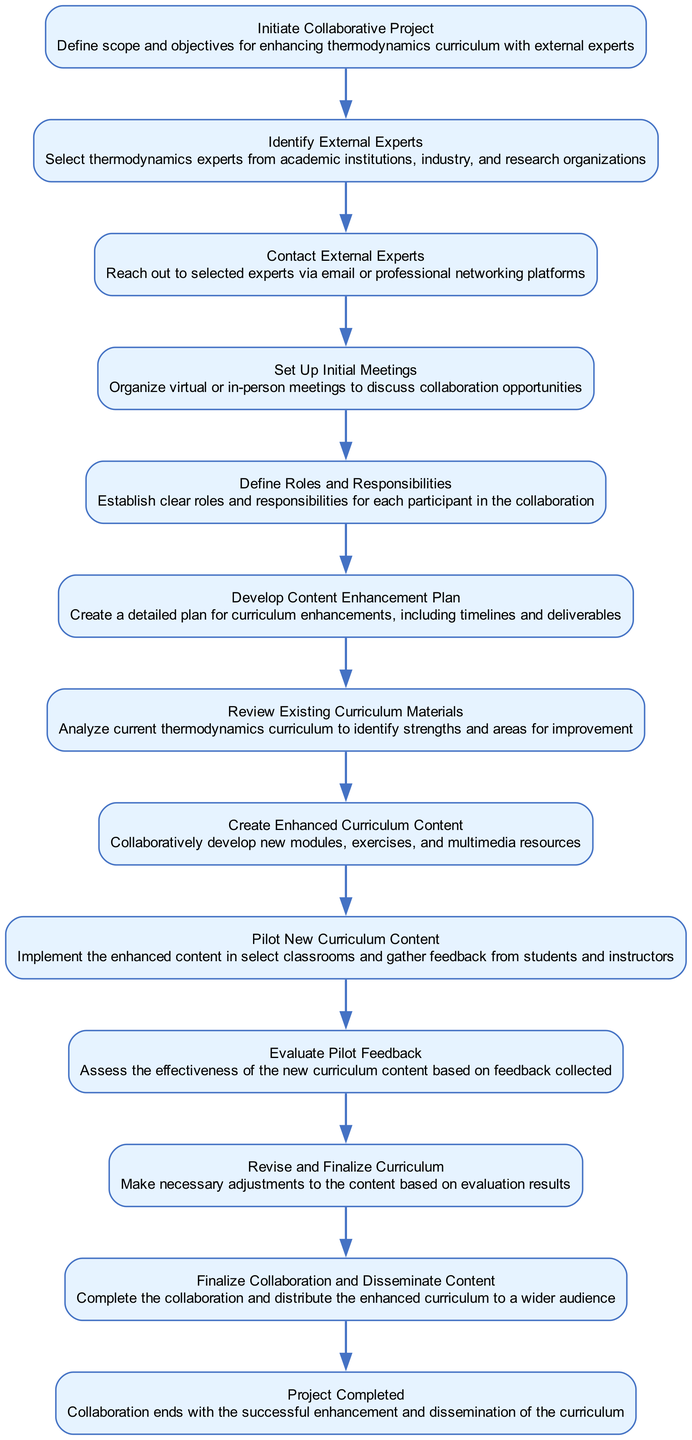What is the starting action of the flowchart? The flowchart begins with the action "Initiate Collaborative Project," which is the first node listed and defines the goal of enhancing the thermodynamics curriculum.
Answer: Initiate Collaborative Project How many nodes are there in the flowchart? There are a total of 12 nodes in the flowchart that detail each step of the collaboration process.
Answer: 12 What is the next action after "Contact External Experts"? After "Contact External Experts," the next action is "Set Up Initial Meetings," indicating the progression in the collaboration process.
Answer: Set Up Initial Meetings Which action follows "Evaluate Pilot Feedback"? The action that follows "Evaluate Pilot Feedback" is "Revise and Finalize Curriculum," which suggests that adjustments will be made based on the evaluation results.
Answer: Revise and Finalize Curriculum What key role is established after "Set Up Initial Meetings"? After setting up initial meetings, the flowchart states the key role is "Define Roles and Responsibilities," which highlights the importance of clarifying participant contributions in the collaboration.
Answer: Define Roles and Responsibilities What type of feedback is gathered during the "Pilot New Curriculum Content" step? During the "Pilot New Curriculum Content" step, feedback is gathered from students and instructors, indicating the collaborative evaluation of the new curriculum's effectiveness.
Answer: Feedback from students and instructors How does the flowchart end? The flowchart concludes with the action "Project Completed," signifying that the curriculum enhancement and dissemination have been successfully accomplished.
Answer: Project Completed Which two actions are linked directly before "Create Enhanced Curriculum Content"? The actions directly before "Create Enhanced Curriculum Content" are "Review Existing Curriculum Materials" and "Develop Content Enhancement Plan," indicating a sequential progression of tasks leading to content creation.
Answer: Review Existing Curriculum Materials and Develop Content Enhancement Plan What is the final output of the collaboration process as per the flowchart? The final output of the collaboration process is "Disseminate Content," which indicates that the enhanced curriculum will be distributed to a larger audience once the project is completed.
Answer: Disseminate Content 